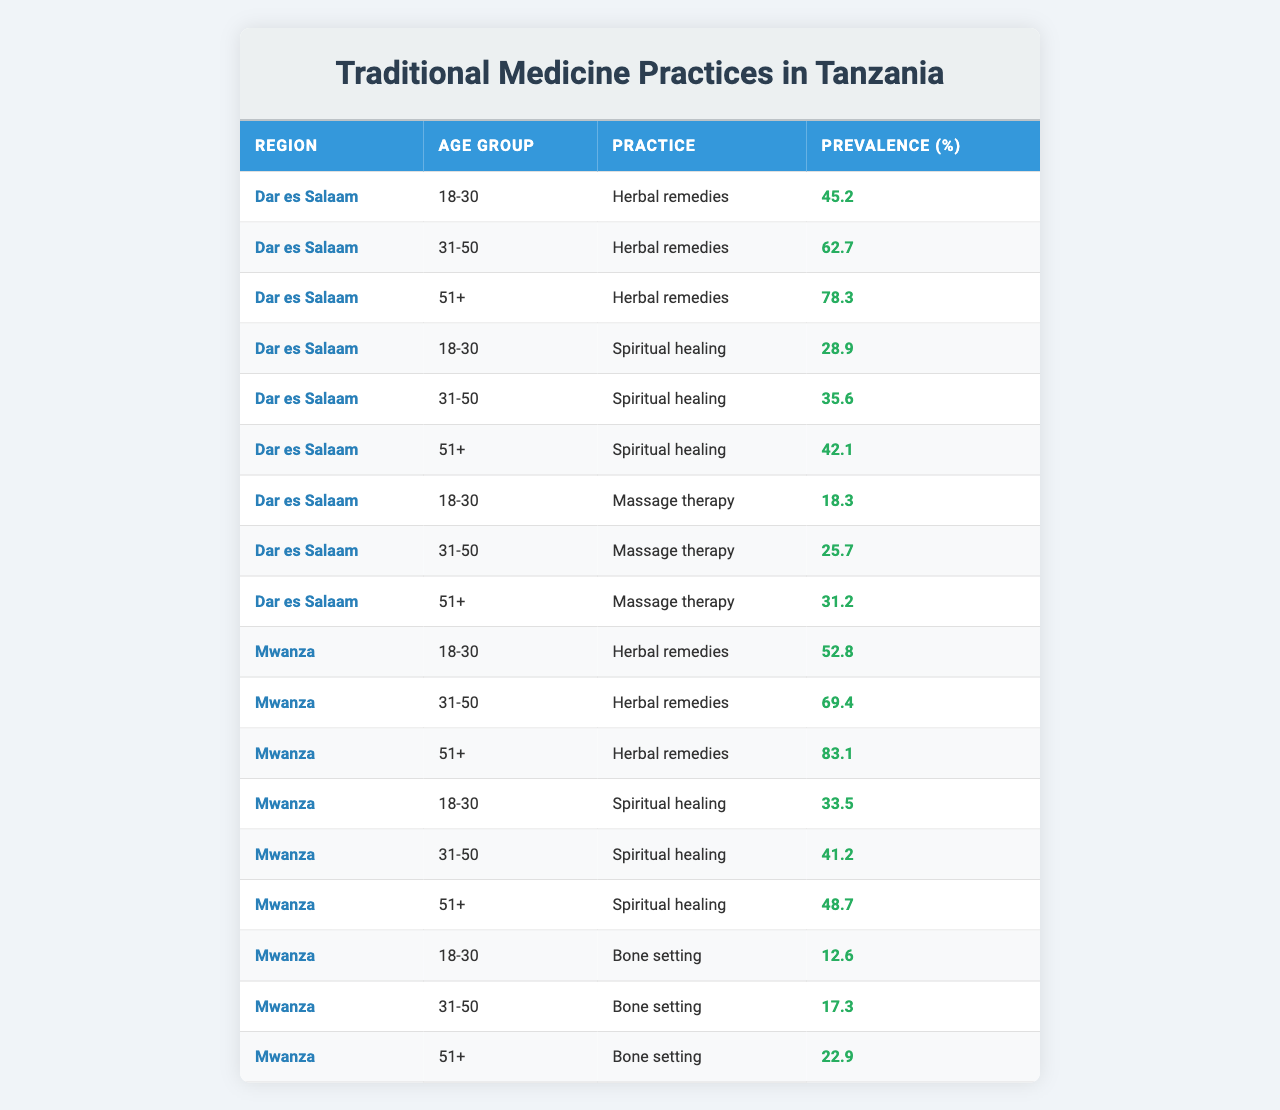What is the prevalence of herbal remedies among the 31-50 age group in Mwanza? In the table, under the Mwanza region and for the age group 31-50, the prevalence of herbal remedies is listed as 69.4%.
Answer: 69.4% Which age group shows the highest prevalence of spiritual healing in Dar es Salaam? In the Dar es Salaam section of the table, we can compare the prevalence of spiritual healing across different age groups. The highest prevalence for spiritual healing is 42.1% in the 51+ age group.
Answer: 51+ What is the difference in prevalence of herbal remedies between the 18-30 and 51+ age groups in Dar es Salaam? The prevalence for herbal remedies among the 18-30 age group is 45.2% and for the 51+ age group, it is 78.3%. The difference is 78.3% - 45.2% = 33.1%.
Answer: 33.1% Is the prevalence of massage therapy higher in the 31-50 age group compared to the 18-30 age group in Mwanza? In Mwanza, the prevalence of massage therapy is 25.7% for the 31-50 age group and 18.3% for the 18-30 age group. Since 25.7% > 18.3%, the statement is true.
Answer: Yes What is the average prevalence of spiritual healing across all age groups in Mwanza? For spiritual healing in Mwanza: 33.5% (18-30) + 41.2% (31-50) + 48.7% (51+) = 123.4%. Dividing by the three age groups (123.4% / 3) gives an average of approximately 41.13%.
Answer: 41.13% Which traditional medicine practice has the highest prevalence among the 51+ age group across both regions? Looking at the 51+ age group, herbal remedies have a prevalence of 78.3% in Dar es Salaam and 83.1% in Mwanza. The higher value is 83.1%, so herbal remedies are the most prevalent.
Answer: Herbal remedies What is the total prevalence of bone setting among all age groups in Mwanza? The prevalence of bone setting in Mwanza for the age groups is: 12.6% (18-30) + 17.3% (31-50) + 22.9% (51+) = 52.8%. Therefore, the total prevalence is 52.8%.
Answer: 52.8% Which region has a higher overall prevalence of herbal remedies for the 18-30 age group? In the table, the 18-30 age group has a prevalence of 45.2% in Dar es Salaam, whereas in Mwanza, it is 52.8%. Comparing both shows that Mwanza has a higher prevalence.
Answer: Mwanza Is it true that the prevalence of massage therapy increases with age in Dar es Salaam? Looking at the data for massage therapy in Dar es Salaam: 18.3% (18-30), 25.7% (31-50), and 31.2% (51+). Since these values increase with age, the statement is true.
Answer: Yes What is the highest prevalence of any traditional medicine practice and among which age group and region is it found? The highest prevalence in the table is 83.1% for herbal remedies among the 51+ age group in Mwanza.
Answer: 83.1% in Mwanza, 51+ age group 